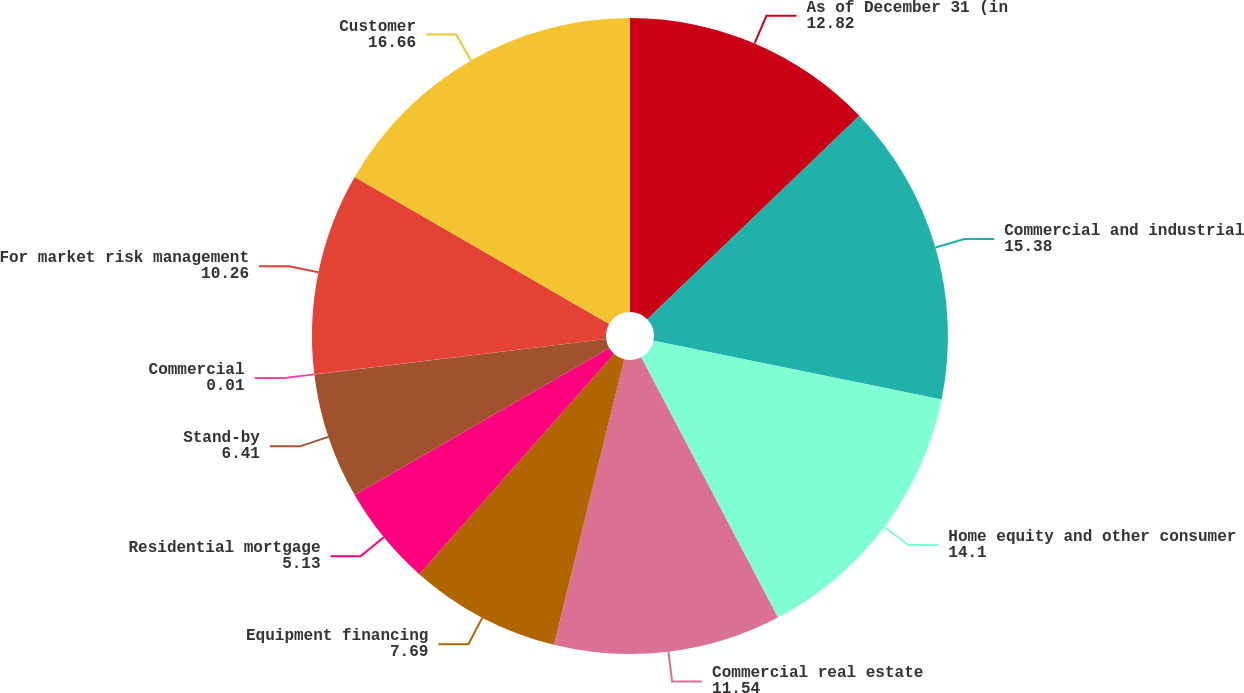<chart> <loc_0><loc_0><loc_500><loc_500><pie_chart><fcel>As of December 31 (in<fcel>Commercial and industrial<fcel>Home equity and other consumer<fcel>Commercial real estate<fcel>Equipment financing<fcel>Residential mortgage<fcel>Stand-by<fcel>Commercial<fcel>For market risk management<fcel>Customer<nl><fcel>12.82%<fcel>15.38%<fcel>14.1%<fcel>11.54%<fcel>7.69%<fcel>5.13%<fcel>6.41%<fcel>0.01%<fcel>10.26%<fcel>16.66%<nl></chart> 